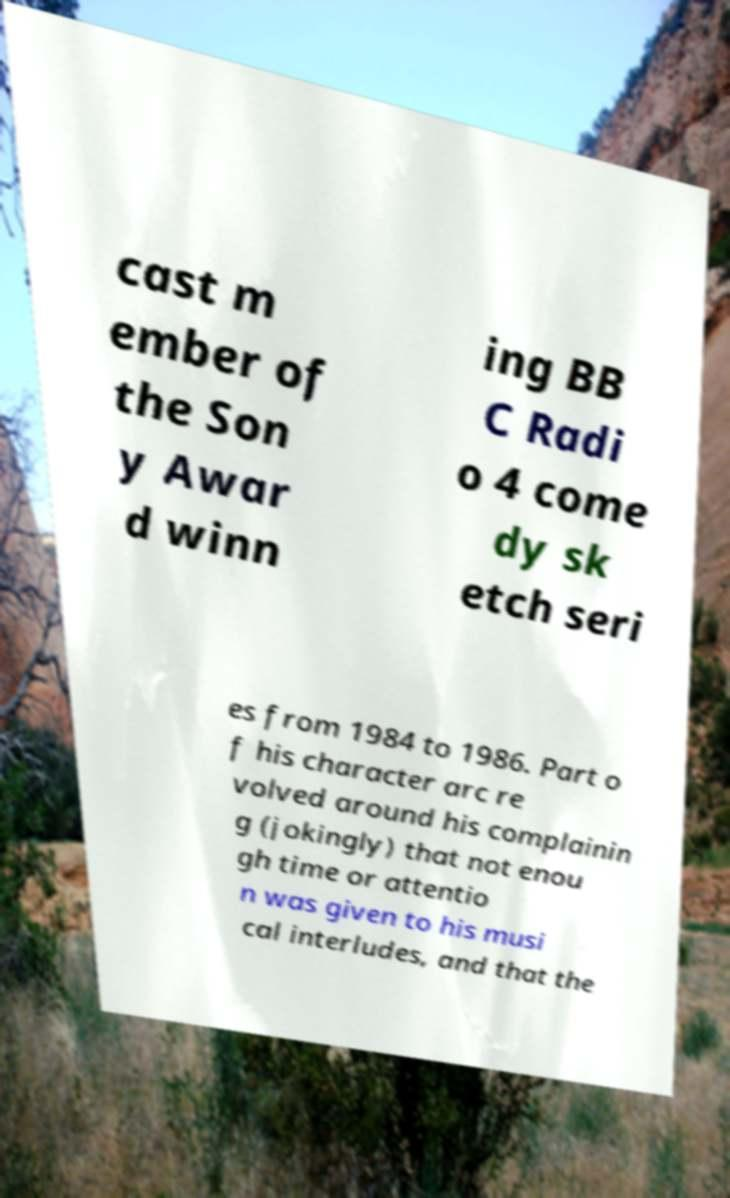What messages or text are displayed in this image? I need them in a readable, typed format. cast m ember of the Son y Awar d winn ing BB C Radi o 4 come dy sk etch seri es from 1984 to 1986. Part o f his character arc re volved around his complainin g (jokingly) that not enou gh time or attentio n was given to his musi cal interludes, and that the 